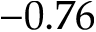Convert formula to latex. <formula><loc_0><loc_0><loc_500><loc_500>- 0 . 7 6</formula> 